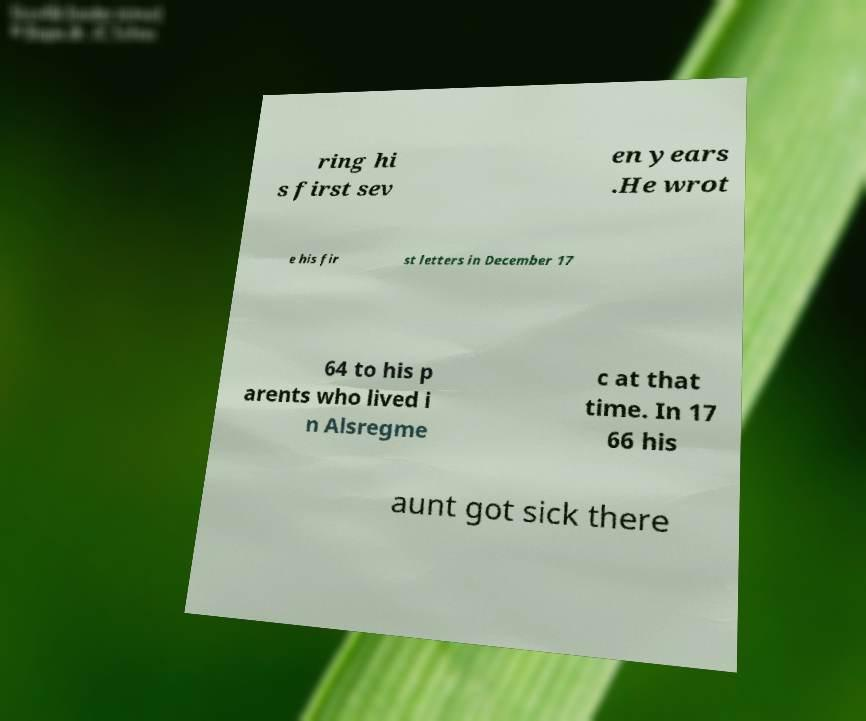Could you assist in decoding the text presented in this image and type it out clearly? ring hi s first sev en years .He wrot e his fir st letters in December 17 64 to his p arents who lived i n Alsregme c at that time. In 17 66 his aunt got sick there 